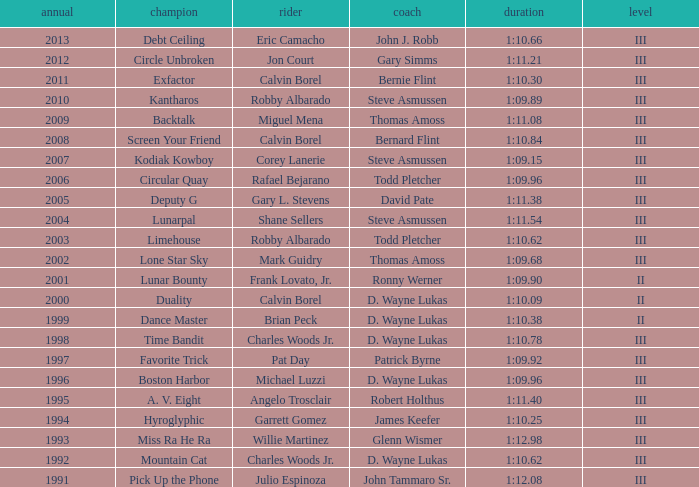Which trainer won the hyroglyphic in a year that was before 2010? James Keefer. 